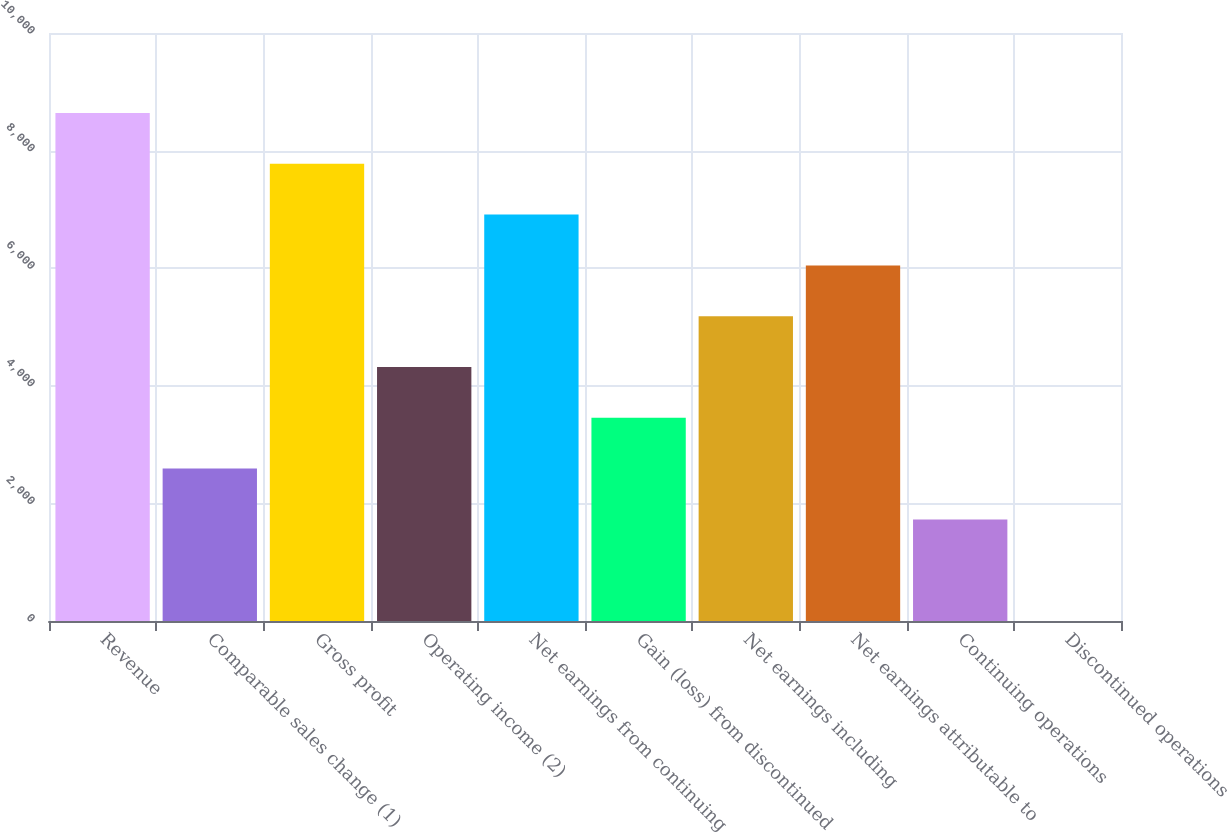<chart> <loc_0><loc_0><loc_500><loc_500><bar_chart><fcel>Revenue<fcel>Comparable sales change (1)<fcel>Gross profit<fcel>Operating income (2)<fcel>Net earnings from continuing<fcel>Gain (loss) from discontinued<fcel>Net earnings including<fcel>Net earnings attributable to<fcel>Continuing operations<fcel>Discontinued operations<nl><fcel>8639.02<fcel>2591.72<fcel>7775.12<fcel>4319.52<fcel>6911.22<fcel>3455.62<fcel>5183.42<fcel>6047.32<fcel>1727.82<fcel>0.02<nl></chart> 